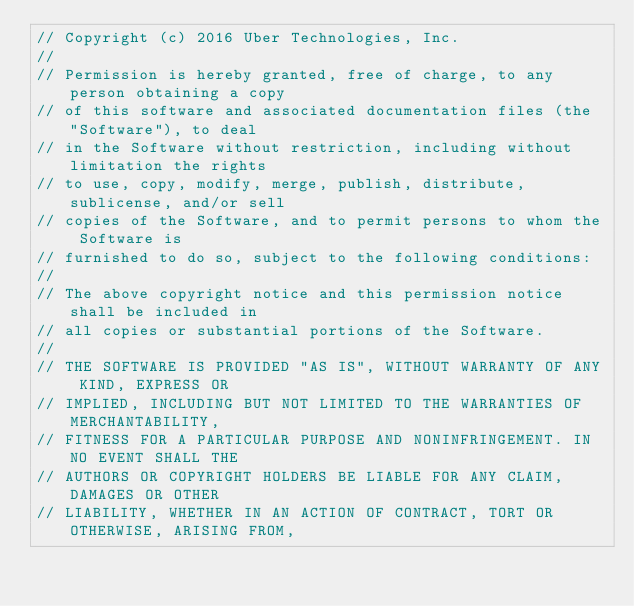<code> <loc_0><loc_0><loc_500><loc_500><_Go_>// Copyright (c) 2016 Uber Technologies, Inc.
//
// Permission is hereby granted, free of charge, to any person obtaining a copy
// of this software and associated documentation files (the "Software"), to deal
// in the Software without restriction, including without limitation the rights
// to use, copy, modify, merge, publish, distribute, sublicense, and/or sell
// copies of the Software, and to permit persons to whom the Software is
// furnished to do so, subject to the following conditions:
//
// The above copyright notice and this permission notice shall be included in
// all copies or substantial portions of the Software.
//
// THE SOFTWARE IS PROVIDED "AS IS", WITHOUT WARRANTY OF ANY KIND, EXPRESS OR
// IMPLIED, INCLUDING BUT NOT LIMITED TO THE WARRANTIES OF MERCHANTABILITY,
// FITNESS FOR A PARTICULAR PURPOSE AND NONINFRINGEMENT. IN NO EVENT SHALL THE
// AUTHORS OR COPYRIGHT HOLDERS BE LIABLE FOR ANY CLAIM, DAMAGES OR OTHER
// LIABILITY, WHETHER IN AN ACTION OF CONTRACT, TORT OR OTHERWISE, ARISING FROM,</code> 